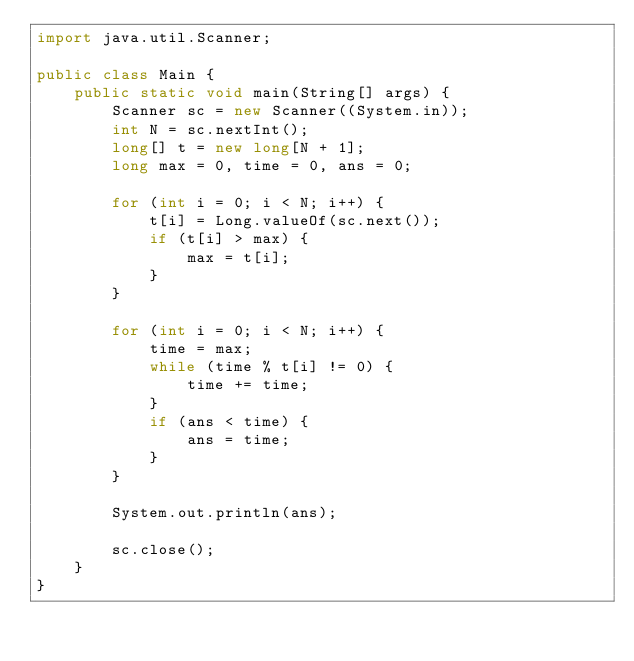Convert code to text. <code><loc_0><loc_0><loc_500><loc_500><_Java_>import java.util.Scanner;

public class Main {
	public static void main(String[] args) {
		Scanner sc = new Scanner((System.in));
		int N = sc.nextInt();
		long[] t = new long[N + 1];
		long max = 0, time = 0, ans = 0;

		for (int i = 0; i < N; i++) {
			t[i] = Long.valueOf(sc.next());
			if (t[i] > max) {
				max = t[i];
			}
		}

		for (int i = 0; i < N; i++) {
			time = max;
			while (time % t[i] != 0) {
				time += time;
			}
			if (ans < time) {
				ans = time;
			}
		}

		System.out.println(ans);

		sc.close();
	}
}</code> 